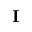Convert formula to latex. <formula><loc_0><loc_0><loc_500><loc_500>I</formula> 